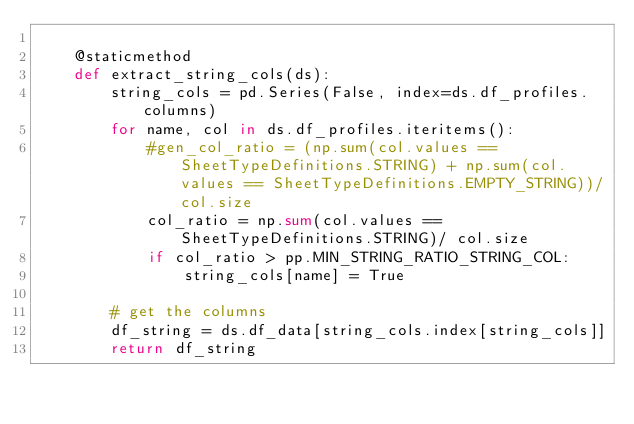<code> <loc_0><loc_0><loc_500><loc_500><_Python_>
    @staticmethod
    def extract_string_cols(ds):
        string_cols = pd.Series(False, index=ds.df_profiles.columns)
        for name, col in ds.df_profiles.iteritems():
            #gen_col_ratio = (np.sum(col.values == SheetTypeDefinitions.STRING) + np.sum(col.values == SheetTypeDefinitions.EMPTY_STRING))/col.size
            col_ratio = np.sum(col.values == SheetTypeDefinitions.STRING)/ col.size
            if col_ratio > pp.MIN_STRING_RATIO_STRING_COL:
                string_cols[name] = True

        # get the columns
        df_string = ds.df_data[string_cols.index[string_cols]]
        return df_string</code> 